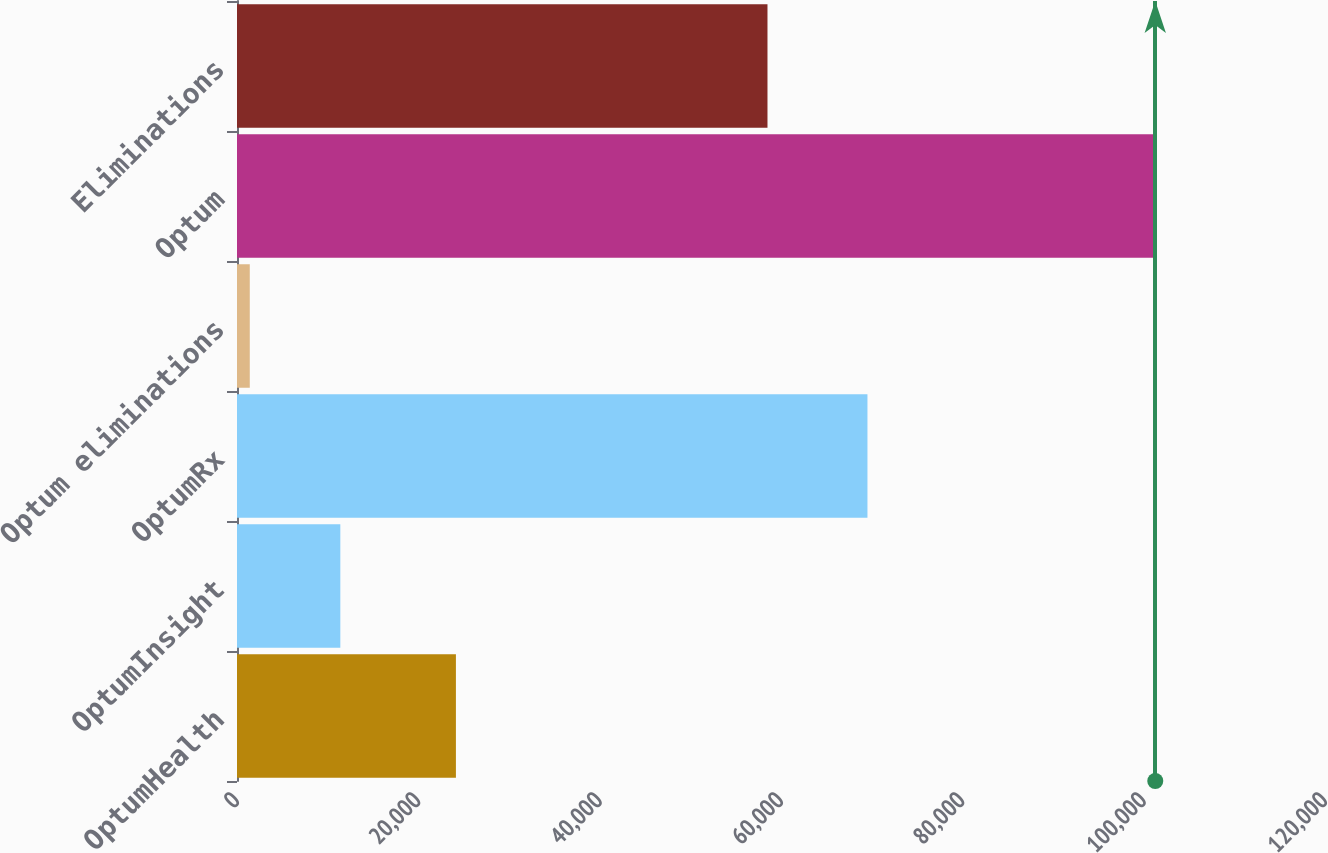Convert chart. <chart><loc_0><loc_0><loc_500><loc_500><bar_chart><fcel>OptumHealth<fcel>OptumInsight<fcel>OptumRx<fcel>Optum eliminations<fcel>Optum<fcel>Eliminations<nl><fcel>24145<fcel>11396.1<fcel>69536<fcel>1409<fcel>101280<fcel>58509<nl></chart> 